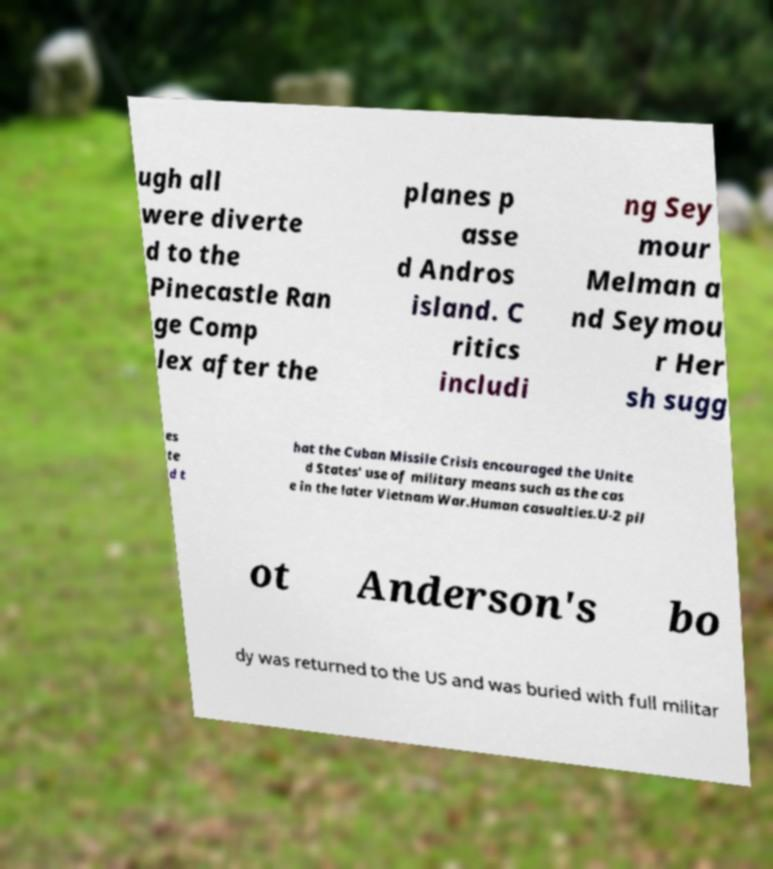Could you extract and type out the text from this image? ugh all were diverte d to the Pinecastle Ran ge Comp lex after the planes p asse d Andros island. C ritics includi ng Sey mour Melman a nd Seymou r Her sh sugg es te d t hat the Cuban Missile Crisis encouraged the Unite d States' use of military means such as the cas e in the later Vietnam War.Human casualties.U-2 pil ot Anderson's bo dy was returned to the US and was buried with full militar 